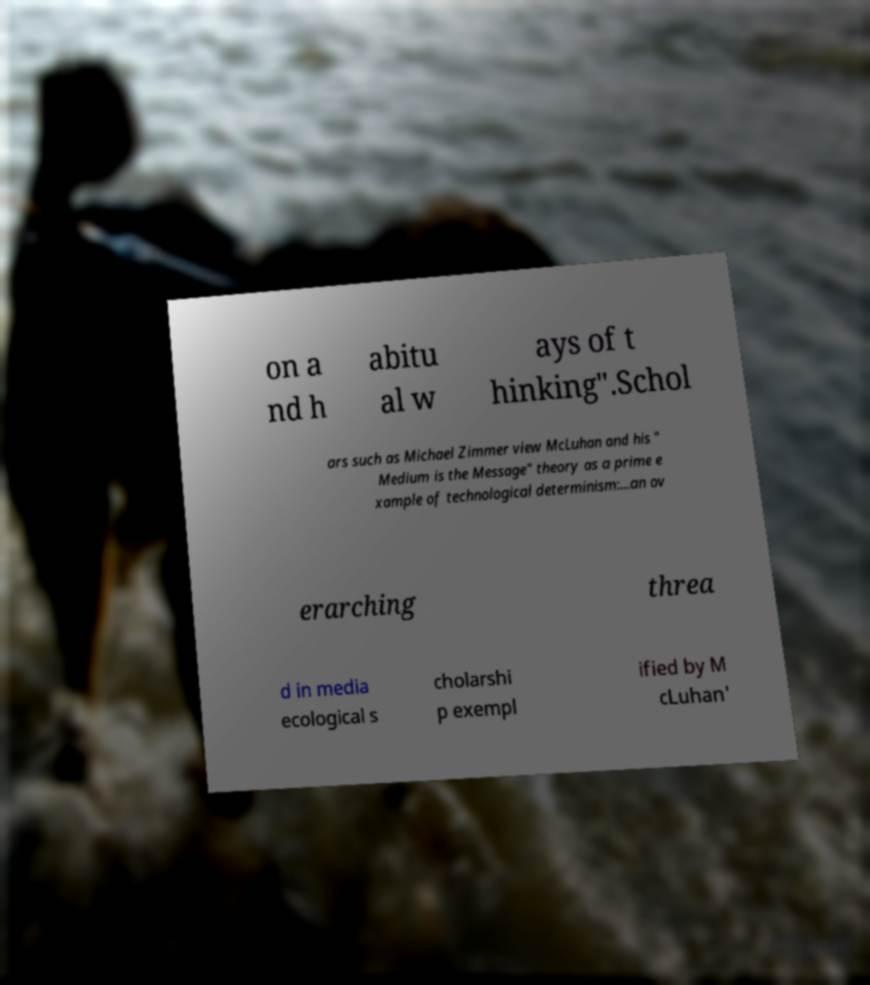Could you extract and type out the text from this image? on a nd h abitu al w ays of t hinking".Schol ars such as Michael Zimmer view McLuhan and his " Medium is the Message" theory as a prime e xample of technological determinism:...an ov erarching threa d in media ecological s cholarshi p exempl ified by M cLuhan' 